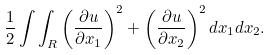<formula> <loc_0><loc_0><loc_500><loc_500>\frac { 1 } { 2 } \int \int _ { R } \left ( \frac { \partial u } { \partial x _ { 1 } } \right ) ^ { 2 } + \left ( \frac { \partial u } { \partial x _ { 2 } } \right ) ^ { 2 } d x _ { 1 } d x _ { 2 } .</formula> 